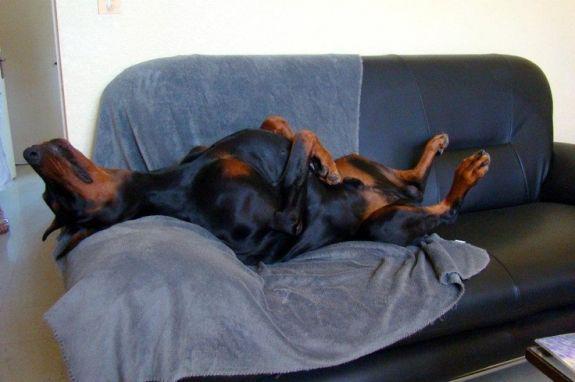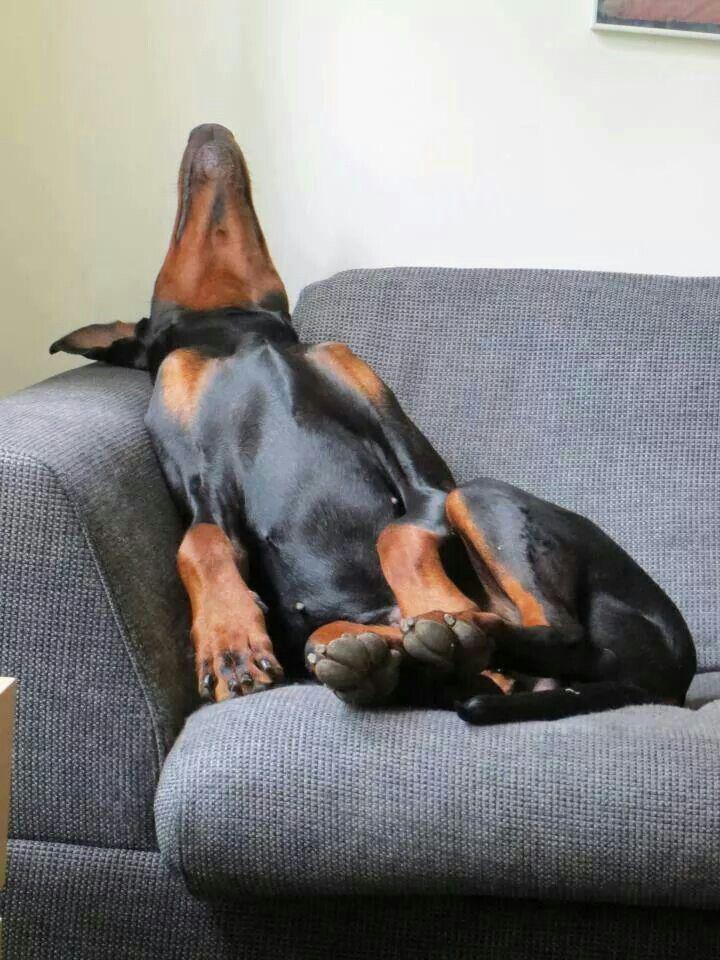The first image is the image on the left, the second image is the image on the right. For the images displayed, is the sentence "The dog in each image is lying on a couch and is asleep." factually correct? Answer yes or no. Yes. The first image is the image on the left, the second image is the image on the right. Considering the images on both sides, is "The left and right image contains the same number of a stretched out dogs using the arm of the sofa as a head rest." valid? Answer yes or no. Yes. 